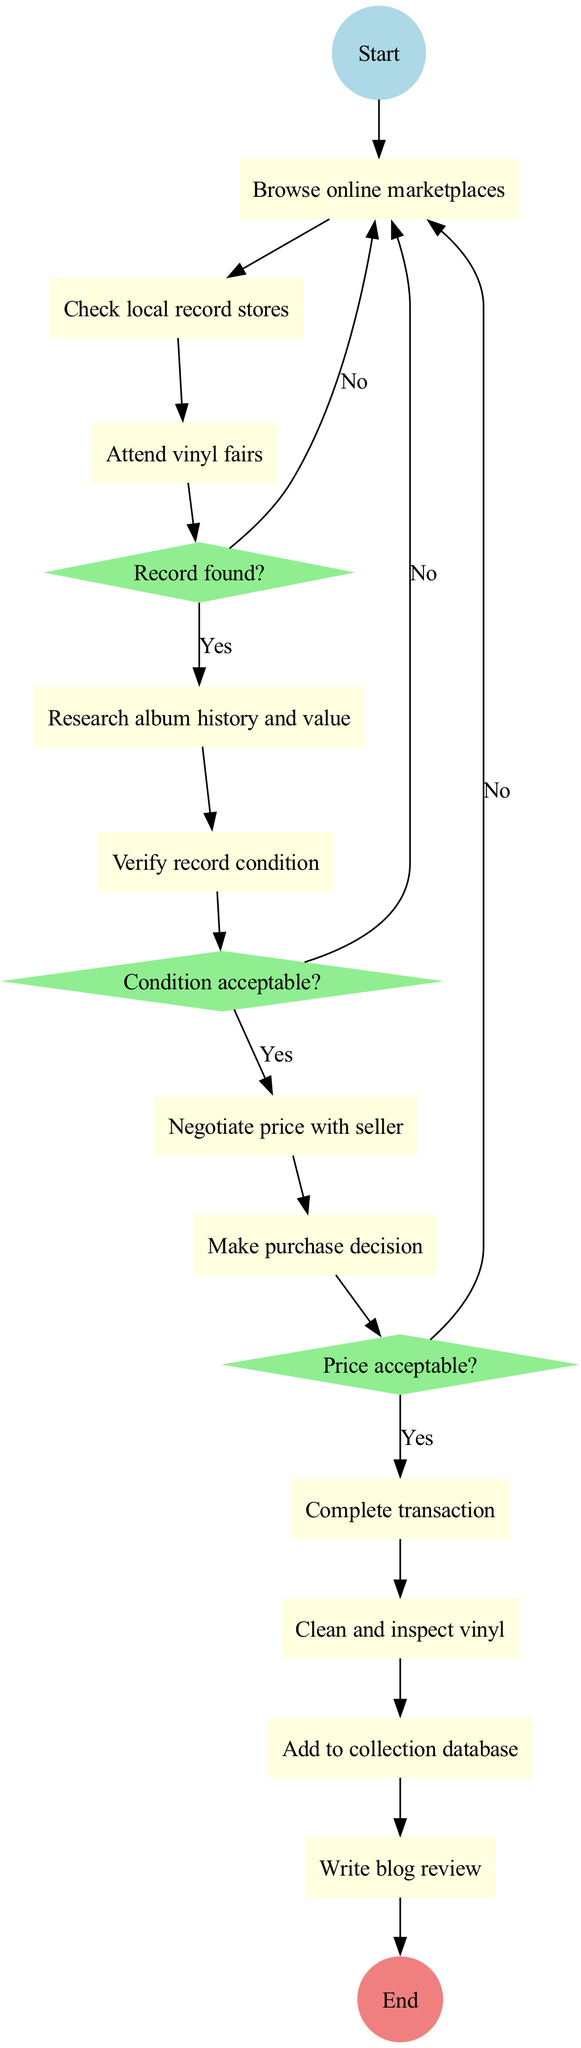What is the starting activity in the acquisition process? The diagram begins with the initial node labeled "Start search for rare jazz vinyl." This indicates that the search for a rare jazz vinyl begins at this point.
Answer: Start search for rare jazz vinyl How many decision points are in the process? The diagram includes three decision points, labeled as "Record found?", "Condition acceptable?", and "Price acceptable?", which each direct the flow based on their outcomes.
Answer: 3 What is the activity that follows "Complete transaction"? After the "Complete transaction", the next activity in the flow is "Clean and inspect vinyl," indicating the next step in the acquisition process.
Answer: Clean and inspect vinyl What happens if the record condition is not acceptable? If the record condition is not acceptable, the diagram directs the flow back to "Continue search," indicating the necessity to find another record instead of moving forward in the purchasing process.
Answer: Continue search What is the final step in the acquisition process? The last activity in the flow is labeled "Write blog review," followed by the ending node "End acquisition process," marking the conclusion of the acquisition.
Answer: Write blog review What is the relationship between "Attend vinyl fairs" and "Record found?" The diagram shows that after attending vinyl fairs, the next step is the decision point "Record found?", which indicates that attending vinyl fairs is a step taken to find a record before checking if one was found.
Answer: Decision point "Record found?" What would you do if you find a record but the price is not acceptable? If the price is not acceptable, the flow indicates to "Continue search," suggesting you must resume looking for a record rather than proceeding with the purchase.
Answer: Continue search What is the first decision you encounter in the process? The first decision encountered in the process is "Record found?", which determines whether to proceed with research or continue searching for records.
Answer: Record found? 